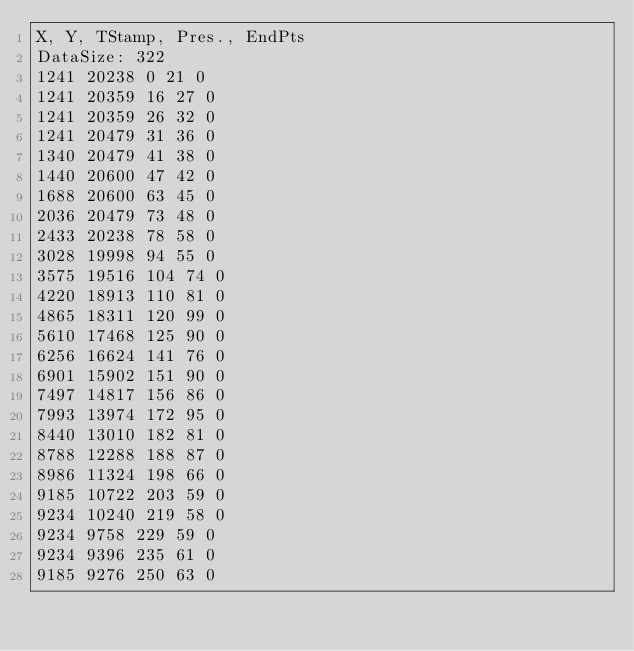<code> <loc_0><loc_0><loc_500><loc_500><_SML_>X, Y, TStamp, Pres., EndPts
DataSize: 322
1241 20238 0 21 0
1241 20359 16 27 0
1241 20359 26 32 0
1241 20479 31 36 0
1340 20479 41 38 0
1440 20600 47 42 0
1688 20600 63 45 0
2036 20479 73 48 0
2433 20238 78 58 0
3028 19998 94 55 0
3575 19516 104 74 0
4220 18913 110 81 0
4865 18311 120 99 0
5610 17468 125 90 0
6256 16624 141 76 0
6901 15902 151 90 0
7497 14817 156 86 0
7993 13974 172 95 0
8440 13010 182 81 0
8788 12288 188 87 0
8986 11324 198 66 0
9185 10722 203 59 0
9234 10240 219 58 0
9234 9758 229 59 0
9234 9396 235 61 0
9185 9276 250 63 0</code> 